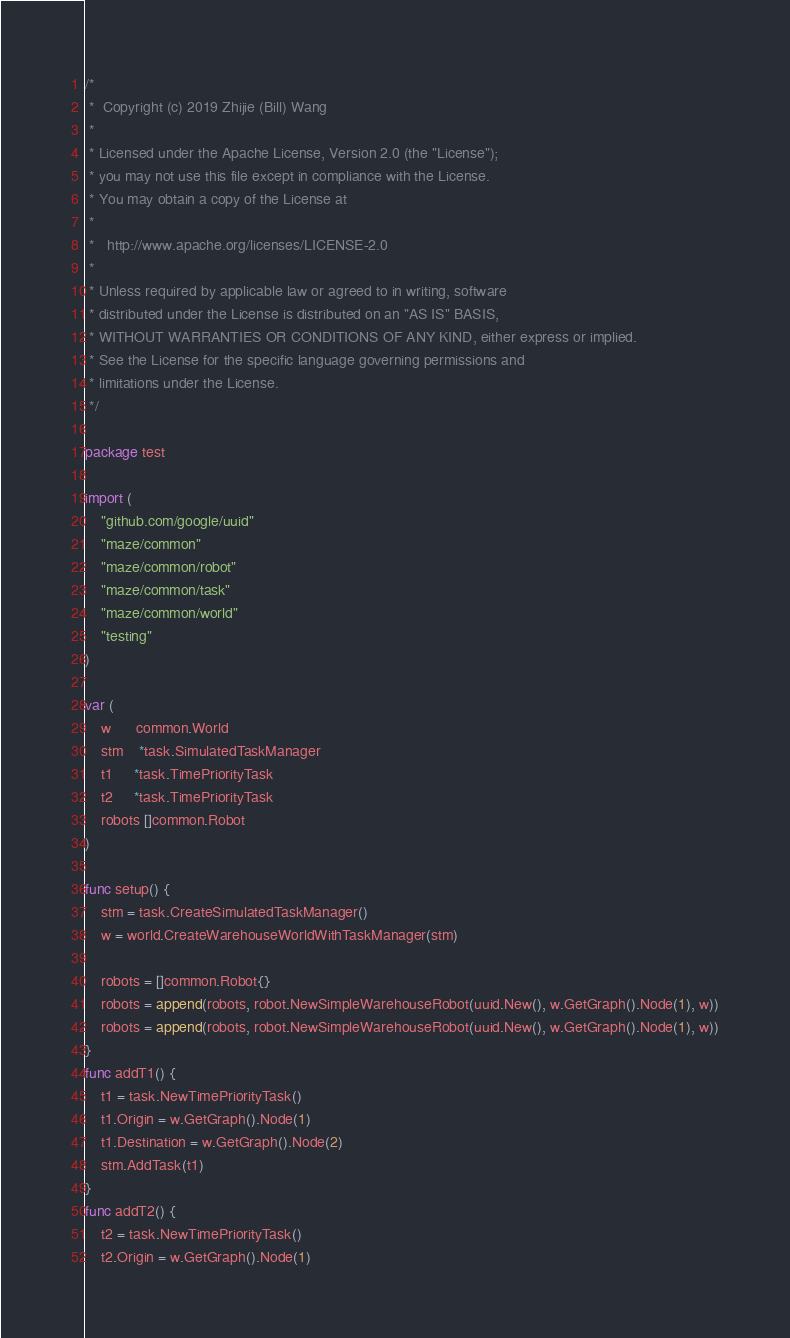Convert code to text. <code><loc_0><loc_0><loc_500><loc_500><_Go_>/*
 *  Copyright (c) 2019 Zhijie (Bill) Wang
 *
 * Licensed under the Apache License, Version 2.0 (the "License");
 * you may not use this file except in compliance with the License.
 * You may obtain a copy of the License at
 *
 *   http://www.apache.org/licenses/LICENSE-2.0
 *
 * Unless required by applicable law or agreed to in writing, software
 * distributed under the License is distributed on an "AS IS" BASIS,
 * WITHOUT WARRANTIES OR CONDITIONS OF ANY KIND, either express or implied.
 * See the License for the specific language governing permissions and
 * limitations under the License.
 */

package test

import (
	"github.com/google/uuid"
	"maze/common"
	"maze/common/robot"
	"maze/common/task"
	"maze/common/world"
	"testing"
)

var (
	w      common.World
	stm    *task.SimulatedTaskManager
	t1     *task.TimePriorityTask
	t2     *task.TimePriorityTask
	robots []common.Robot
)

func setup() {
	stm = task.CreateSimulatedTaskManager()
	w = world.CreateWarehouseWorldWithTaskManager(stm)

	robots = []common.Robot{}
	robots = append(robots, robot.NewSimpleWarehouseRobot(uuid.New(), w.GetGraph().Node(1), w))
	robots = append(robots, robot.NewSimpleWarehouseRobot(uuid.New(), w.GetGraph().Node(1), w))
}
func addT1() {
	t1 = task.NewTimePriorityTask()
	t1.Origin = w.GetGraph().Node(1)
	t1.Destination = w.GetGraph().Node(2)
	stm.AddTask(t1)
}
func addT2() {
	t2 = task.NewTimePriorityTask()
	t2.Origin = w.GetGraph().Node(1)</code> 